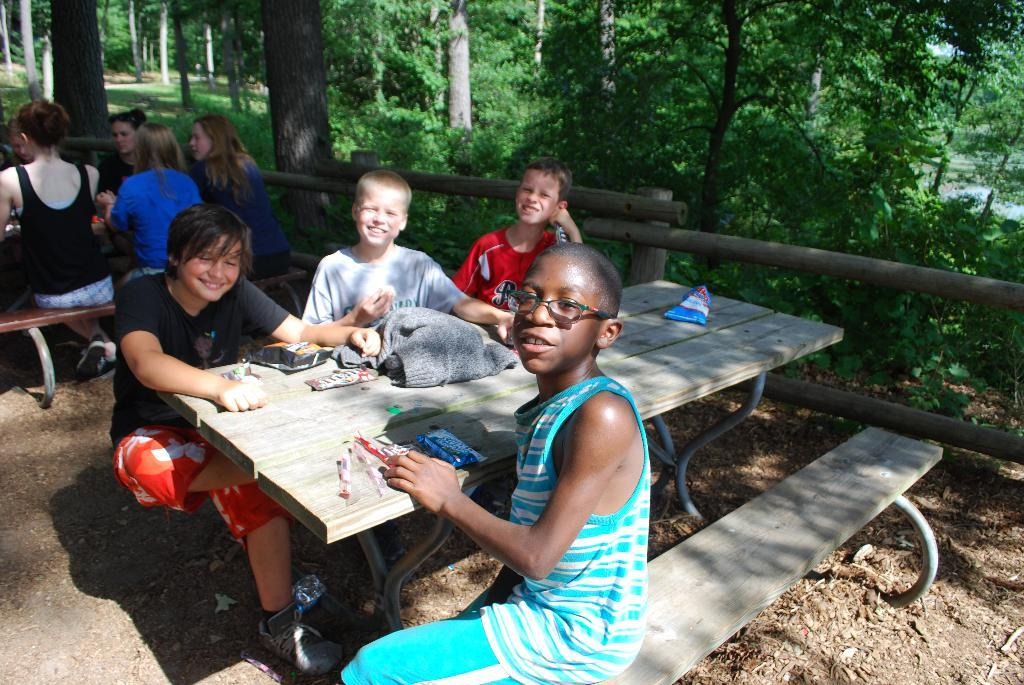What type of vegetation is present on the side of the image? There are trees on the side of the image. What are the people in the image doing? The people in the image are seated on a bench. Can you describe the boy in the image? The boy in the image is wearing spectacles. How are the people in the image feeling? The people in the image have smiles on their faces, which suggests they are happy or enjoying themselves. What type of grain is being harvested by the boy in the image? There is no grain present in the image, nor is the boy engaged in any harvesting activity. What fact can be learned about the people in the image from their smiles? The smiles on the people's faces suggest that they are happy or enjoying themselves, but it does not reveal any specific fact about them. 